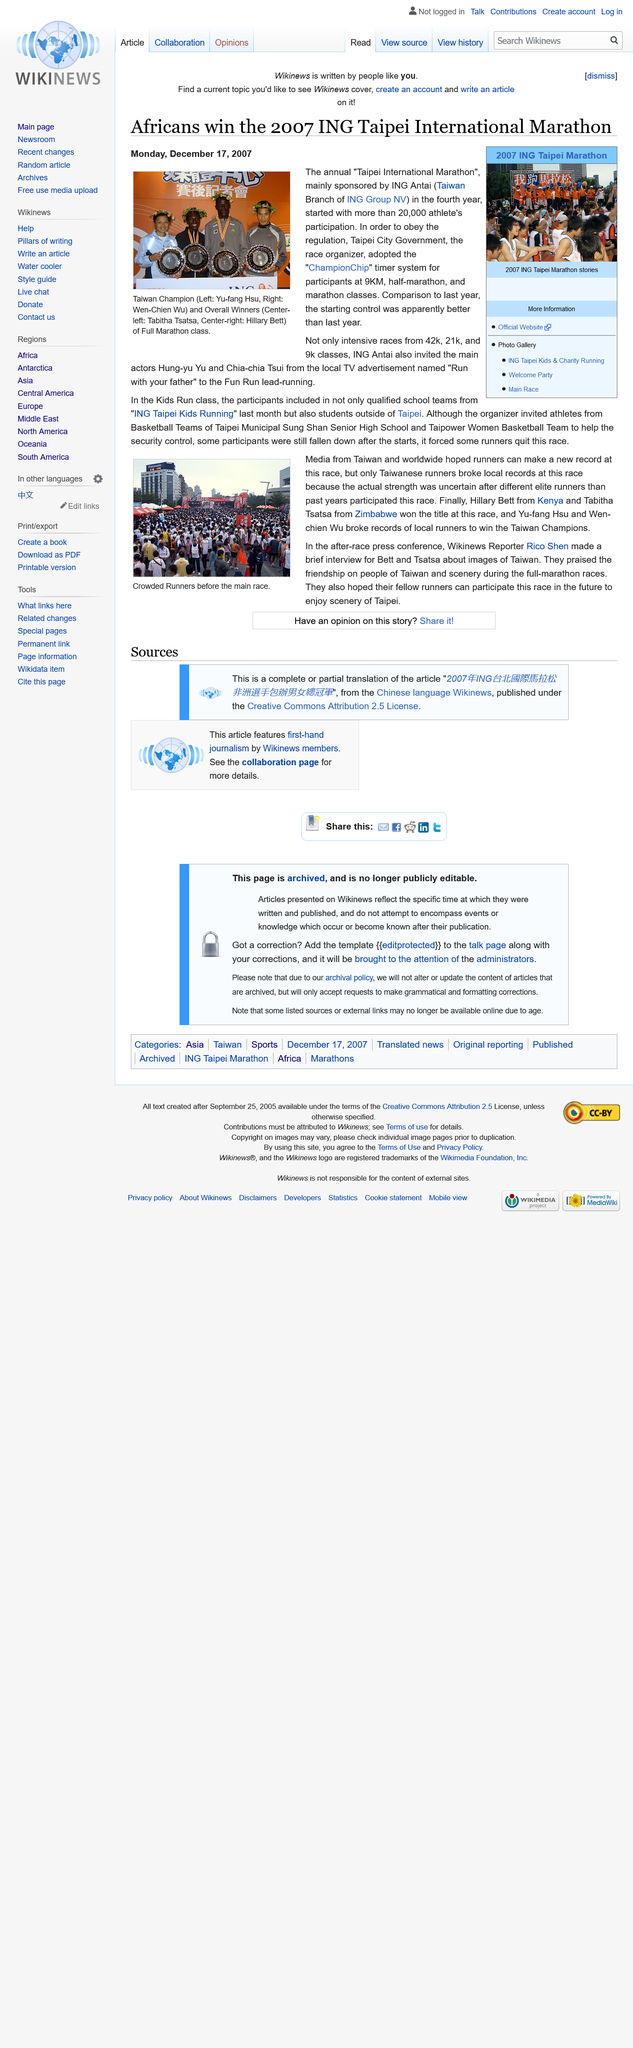Outline some significant characteristics in this image. Hillary Bett is from Kenya. The name of the Wikinews reporter is Rico Shen. The photograph depicts a crowded scene of runners gathered before the start of the main race. The overall winners were considered to be 4 people. The article was published on December 17th, 2007. 